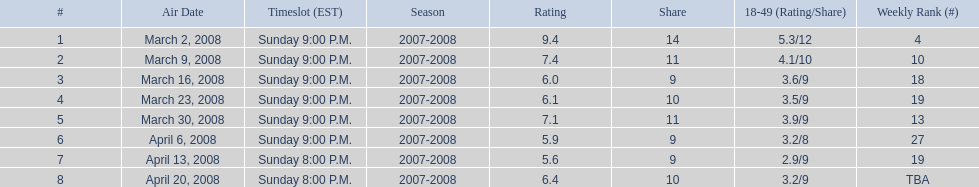How long did the program air for in days? 8. 